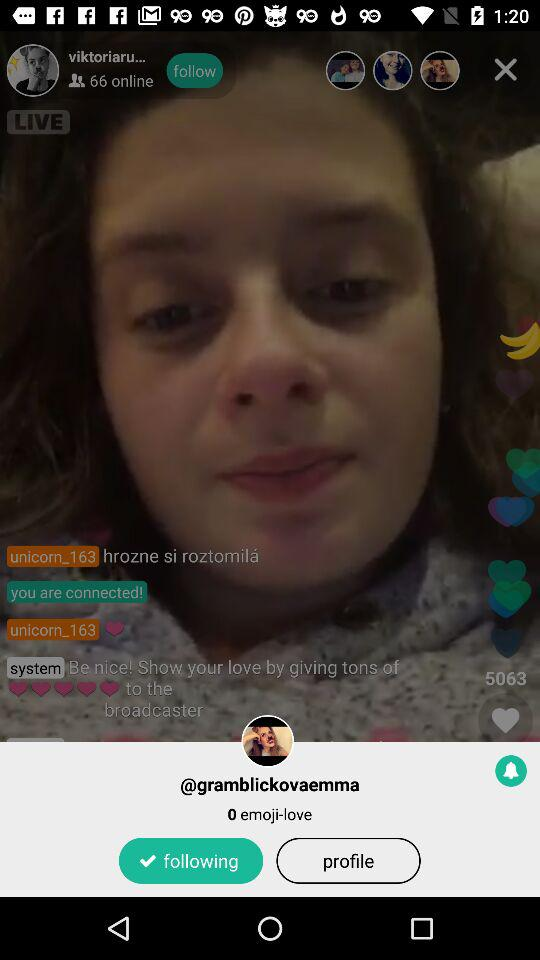Which option is selected?
When the provided information is insufficient, respond with <no answer>. <no answer> 